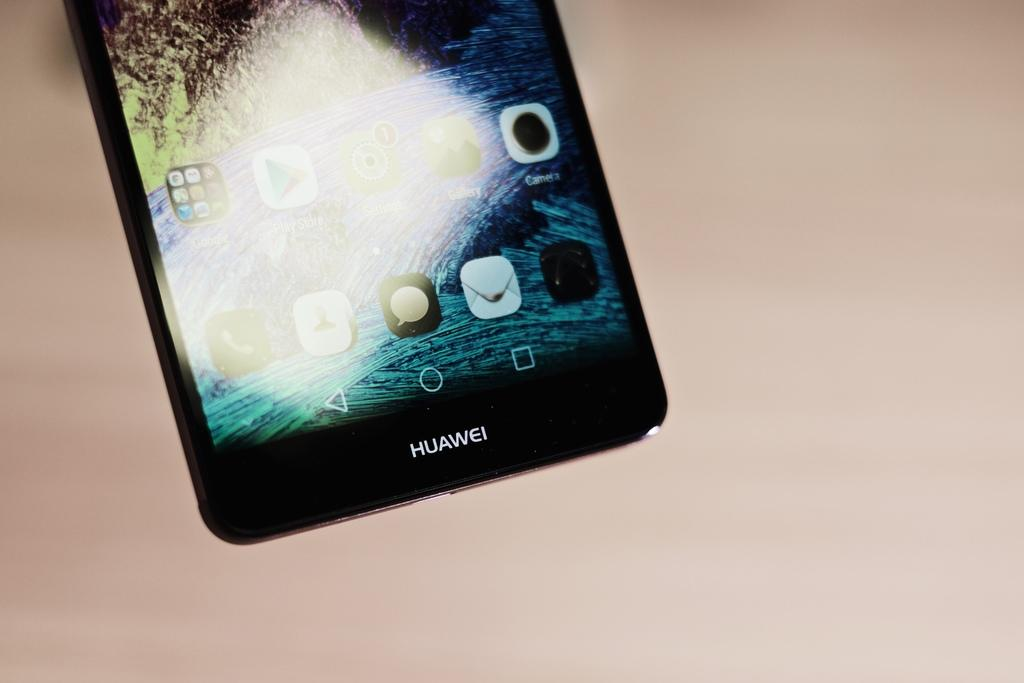<image>
Share a concise interpretation of the image provided. A black Huawei brand smartphone placed on a table 